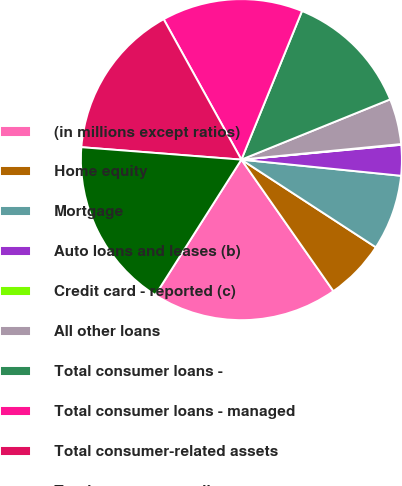<chart> <loc_0><loc_0><loc_500><loc_500><pie_chart><fcel>(in millions except ratios)<fcel>Home equity<fcel>Mortgage<fcel>Auto loans and leases (b)<fcel>Credit card - reported (c)<fcel>All other loans<fcel>Total consumer loans -<fcel>Total consumer loans - managed<fcel>Total consumer-related assets<fcel>Total consumer credit<nl><fcel>18.73%<fcel>6.09%<fcel>7.59%<fcel>3.08%<fcel>0.07%<fcel>4.58%<fcel>12.71%<fcel>14.21%<fcel>15.72%<fcel>17.22%<nl></chart> 